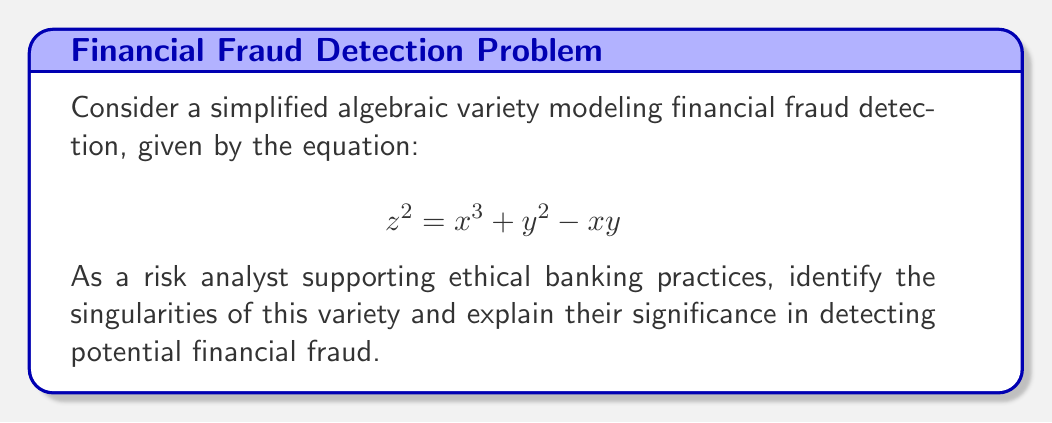Show me your answer to this math problem. To find the singularities of the given algebraic variety, we need to follow these steps:

1) First, we need to find the partial derivatives of the equation with respect to x, y, and z:

   $$\frac{\partial F}{\partial x} = 3x^2 - y$$
   $$\frac{\partial F}{\partial y} = 2y - x$$
   $$\frac{\partial F}{\partial z} = 2z$$

2) Singularities occur at points where all partial derivatives are simultaneously zero and the point satisfies the original equation. So, we need to solve:

   $$3x^2 - y = 0$$
   $$2y - x = 0$$
   $$2z = 0$$
   $$z^2 = x^3 + y^2 - xy$$

3) From the third equation, we can deduce that $z = 0$.

4) From the second equation, we can express y in terms of x:
   $$y = \frac{x}{2}$$

5) Substituting this into the first equation:
   $$3x^2 - \frac{x}{2} = 0$$
   $$6x^2 - x = 0$$
   $$x(6x - 1) = 0$$

6) Solving this, we get $x = 0$ or $x = \frac{1}{6}$

7) When $x = 0$, $y = 0$ as well.
   When $x = \frac{1}{6}$, $y = \frac{1}{12}$

8) We need to check if these points satisfy the original equation:
   For (0,0,0): $0^2 = 0^3 + 0^2 - 0 \cdot 0$ (satisfied)
   For $(\frac{1}{6}, \frac{1}{12}, 0)$: $0^2 = (\frac{1}{6})^3 + (\frac{1}{12})^2 - \frac{1}{6} \cdot \frac{1}{12}$ (satisfied)

Therefore, the singularities are (0,0,0) and $(\frac{1}{6}, \frac{1}{12}, 0)$.

In the context of financial fraud detection, these singularities represent critical points in the model where the behavior of the system changes abruptly. They could indicate thresholds or patterns in financial data that might signal potential fraudulent activities. For a risk analyst, these points warrant extra scrutiny as they might represent sophisticated attempts to conceal fraud by operating at the edges of typical detection methods.
Answer: (0,0,0) and $(\frac{1}{6}, \frac{1}{12}, 0)$ 